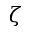<formula> <loc_0><loc_0><loc_500><loc_500>\zeta</formula> 